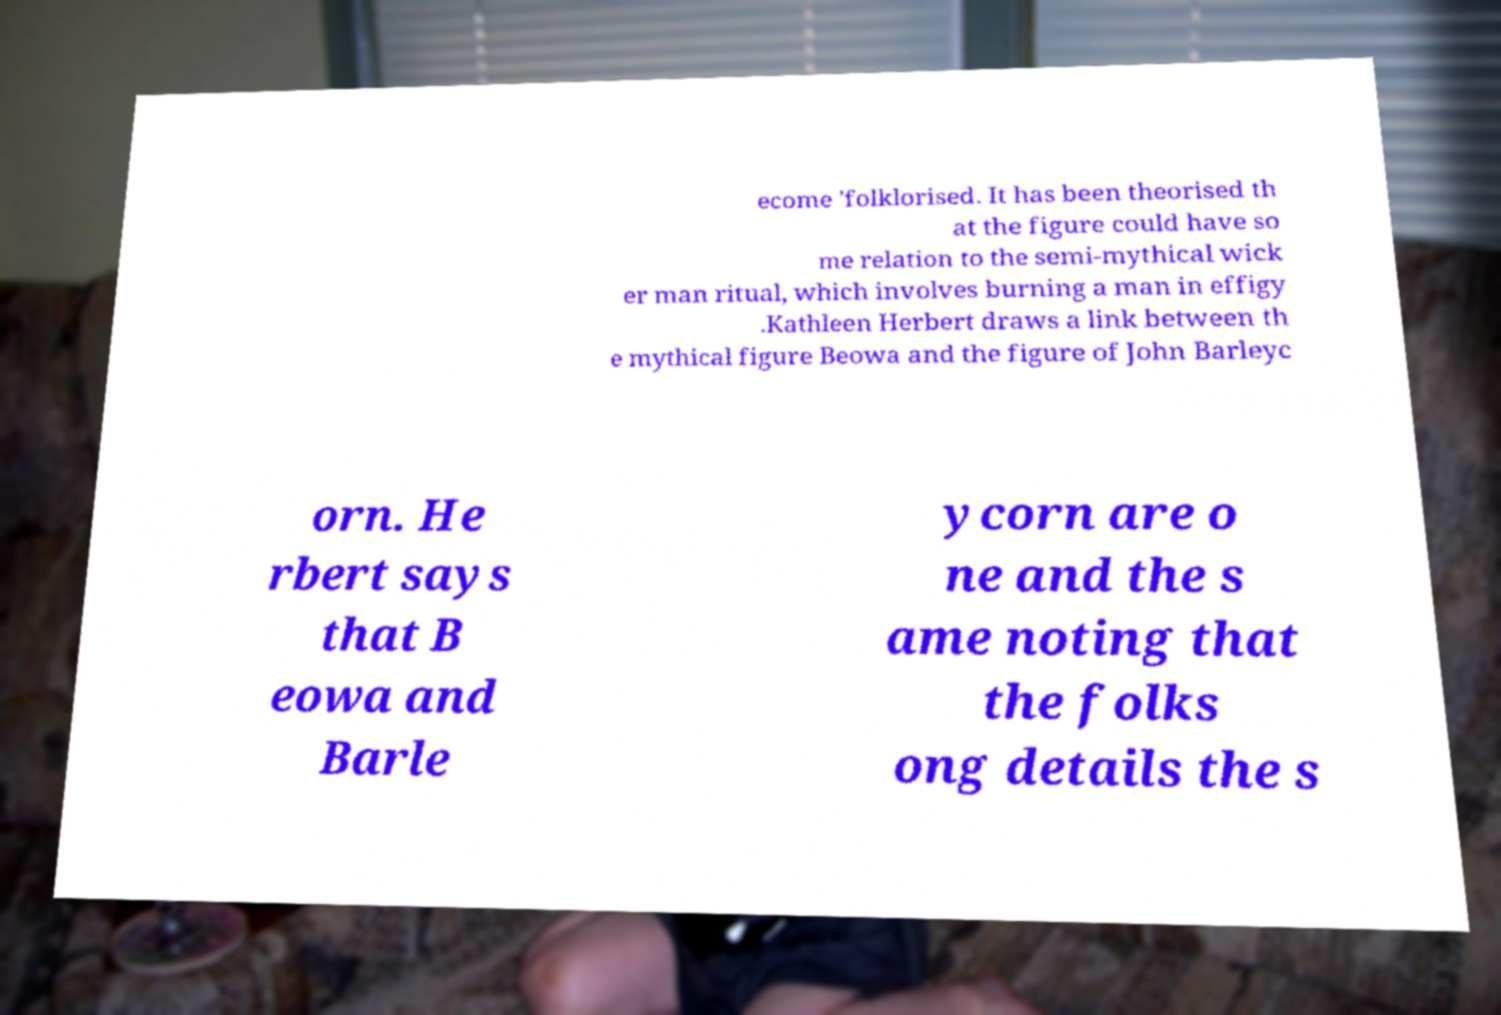Can you accurately transcribe the text from the provided image for me? ecome 'folklorised. It has been theorised th at the figure could have so me relation to the semi-mythical wick er man ritual, which involves burning a man in effigy .Kathleen Herbert draws a link between th e mythical figure Beowa and the figure of John Barleyc orn. He rbert says that B eowa and Barle ycorn are o ne and the s ame noting that the folks ong details the s 